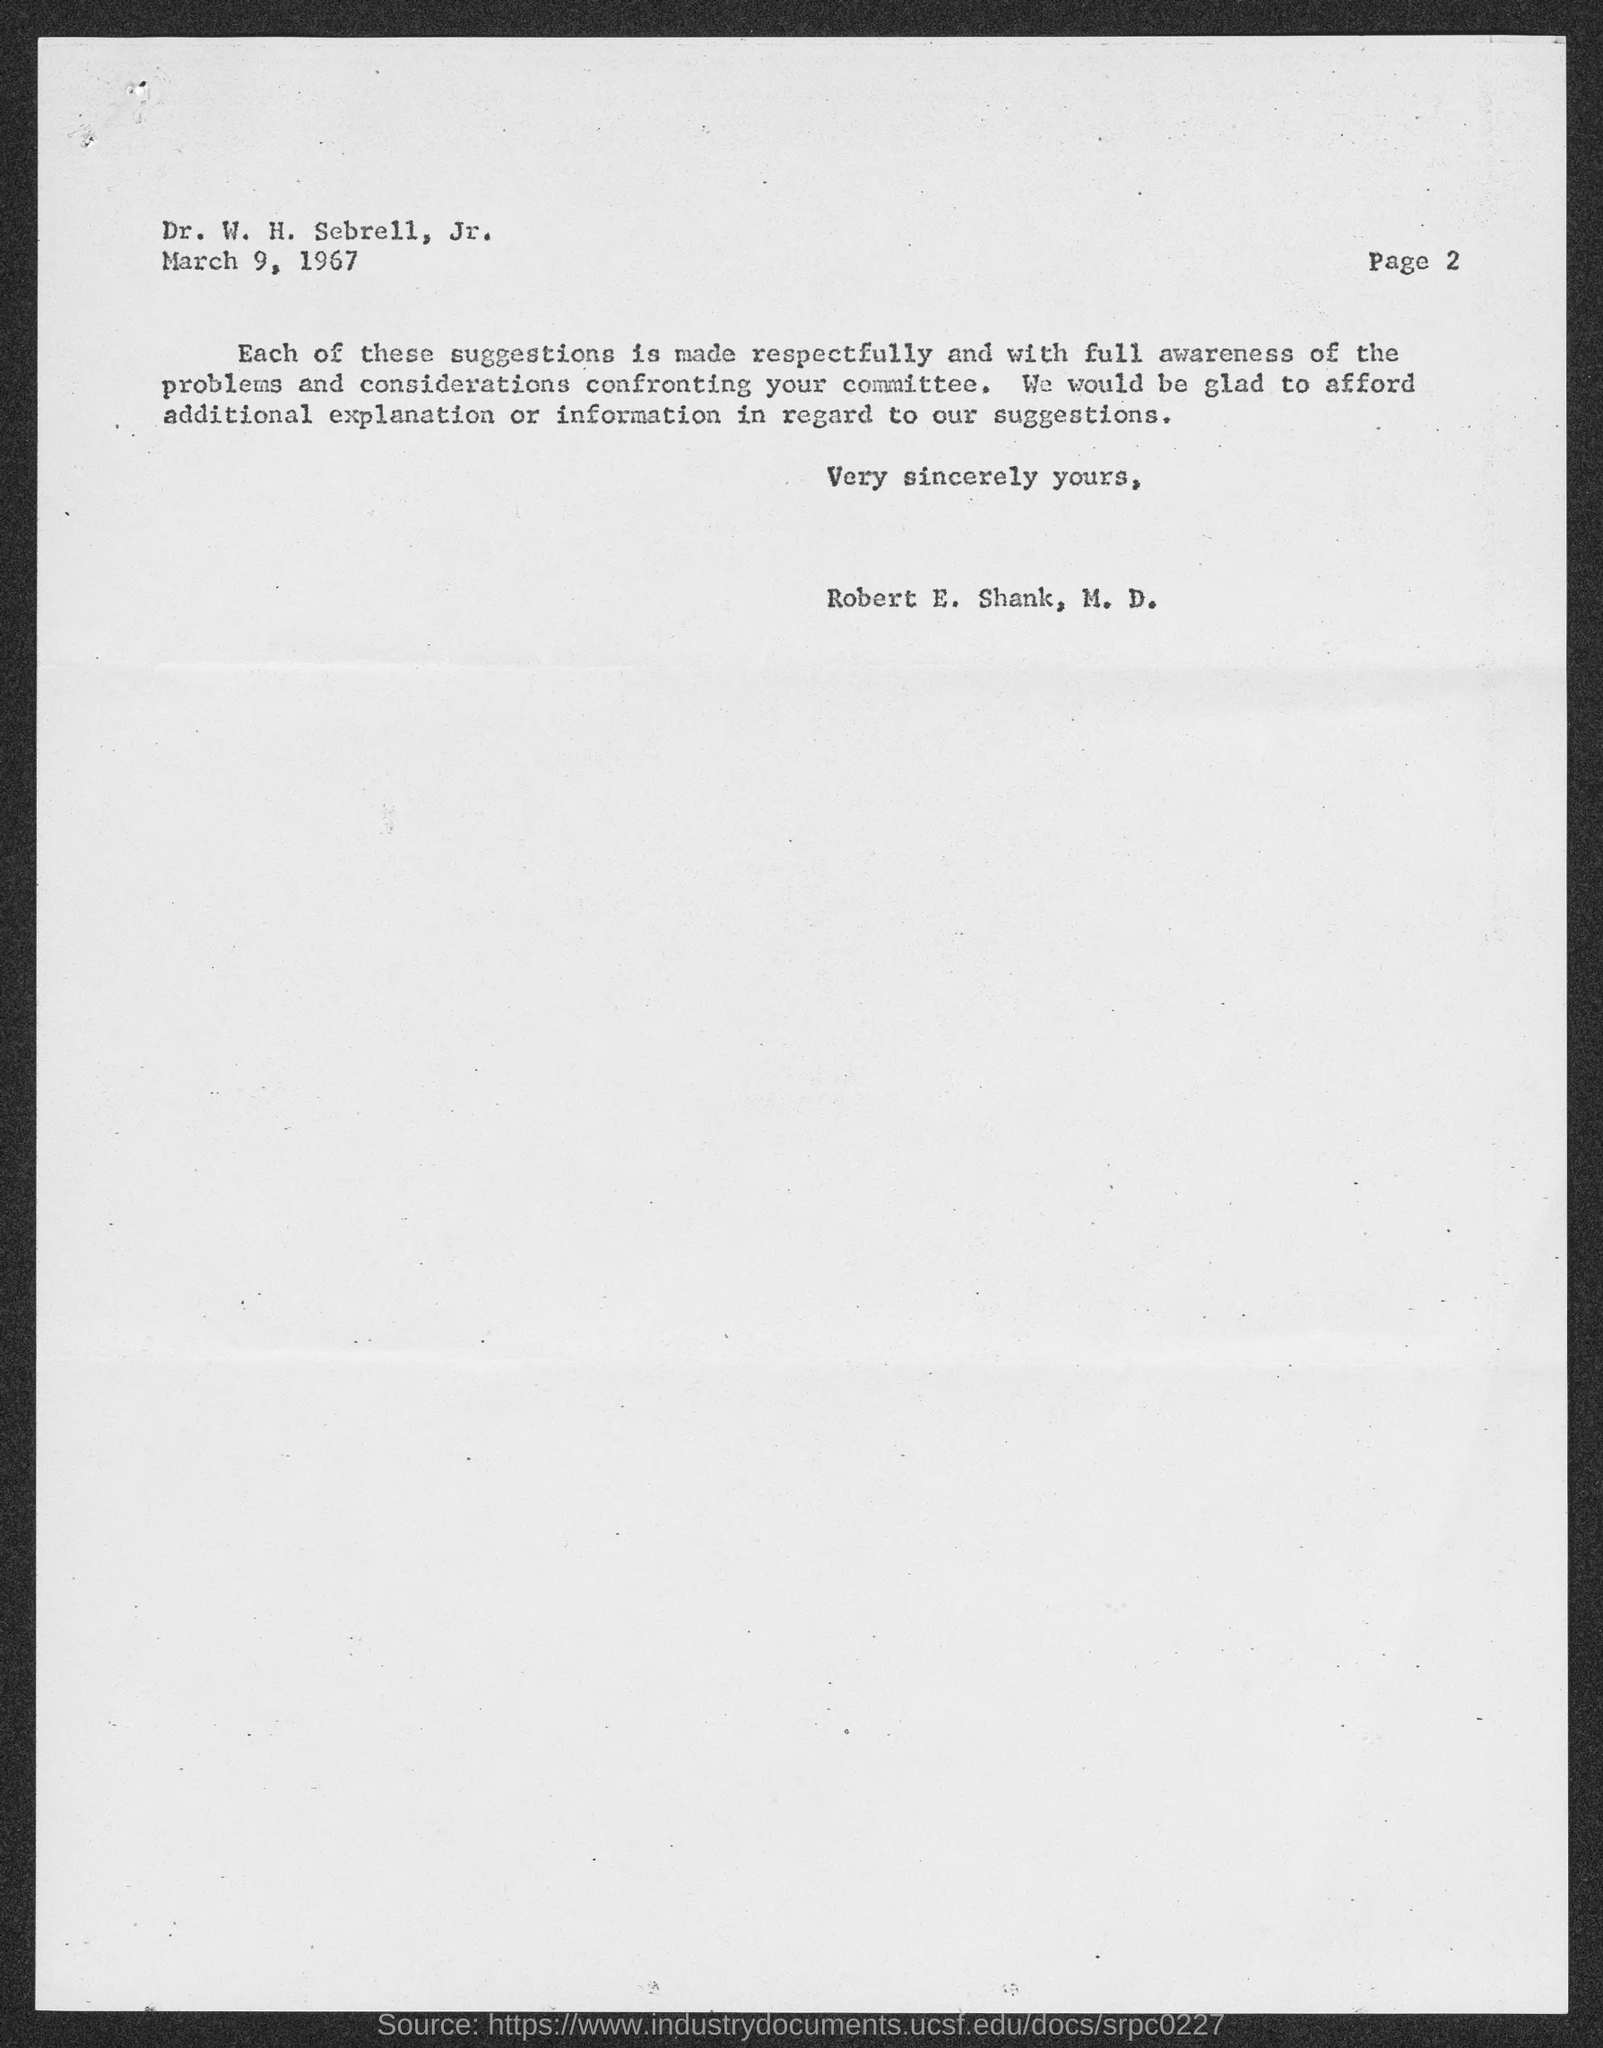What is the Page number written in the document ?
Keep it short and to the point. Page 2. When is the memorandum dated on ?
Make the answer very short. March 9, 1967. 